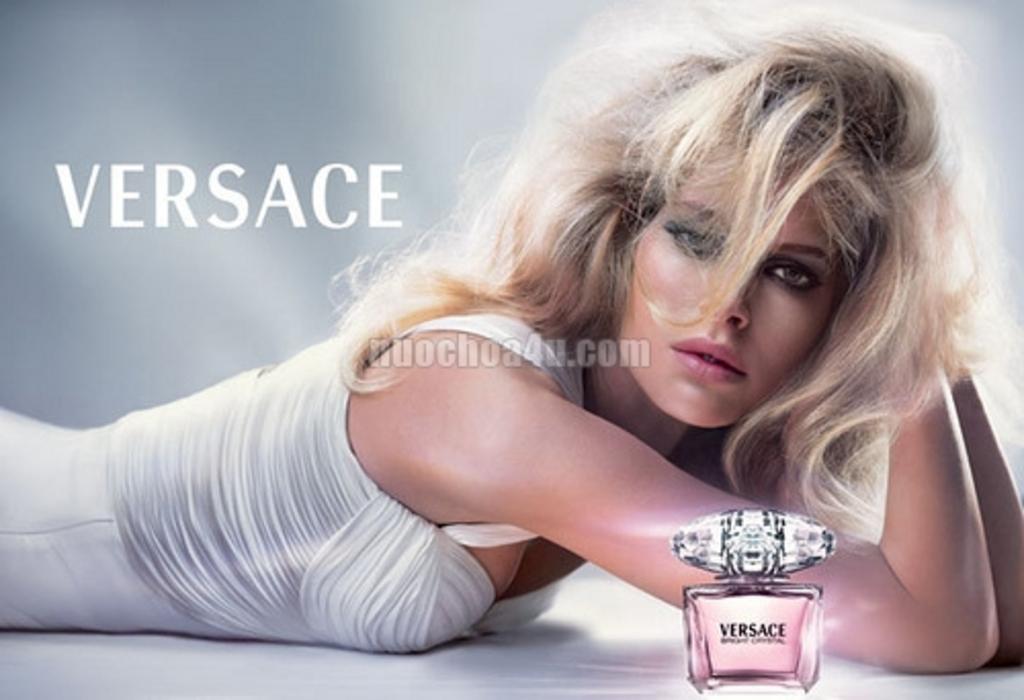What brand is being featured?
Your answer should be compact. Versace. 